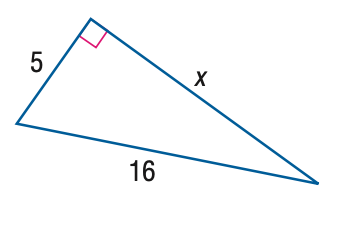Question: Find x. Round to the nearest hundredth.
Choices:
A. 15.20
B. 15.84
C. 16.16
D. 16.76
Answer with the letter. Answer: A 